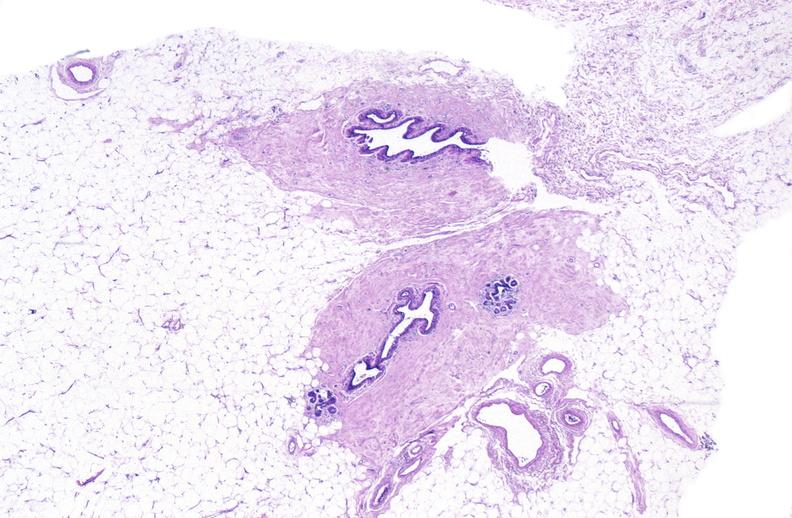what does this image show?
Answer the question using a single word or phrase. Normal breast 